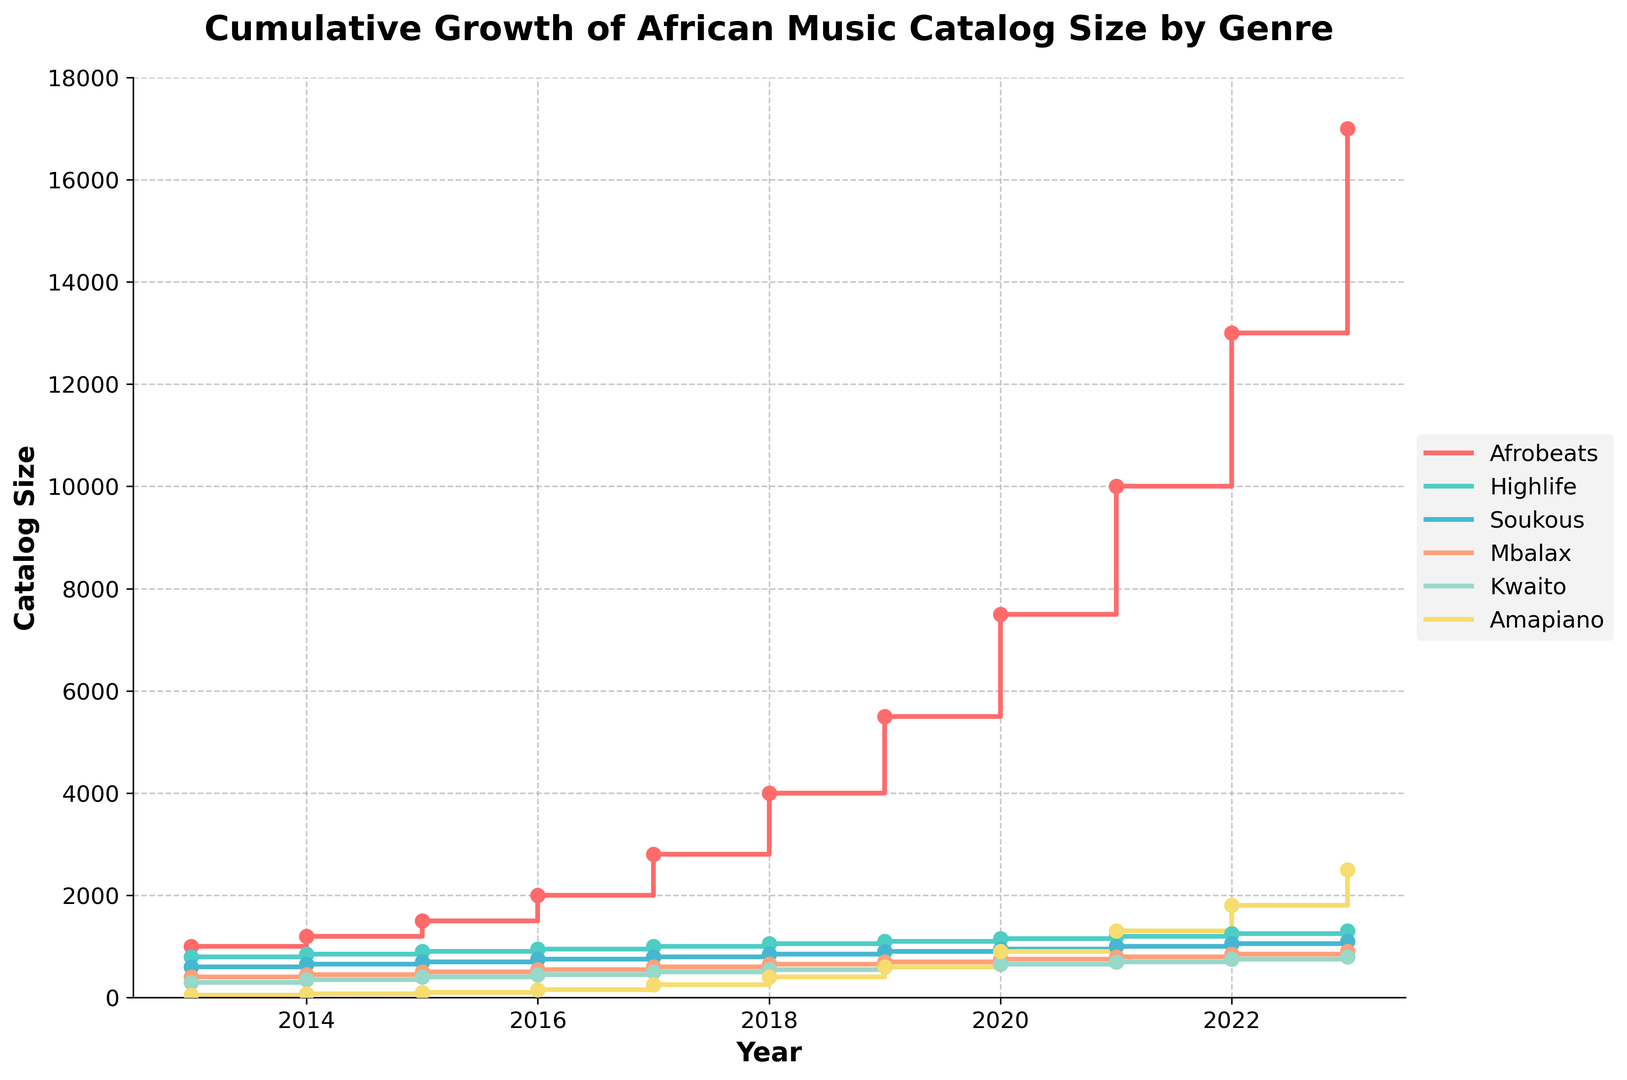Which genre has the largest catalog size growth between 2013 and 2023? To determine this, we need to look at the starting and ending catalog sizes for each genre in 2013 and 2023, respectively. Afrobeats grows from 1000 to 17000, Highlife from 800 to 1300, Soukous from 600 to 1100, Mbalax from 400 to 900, Kwaito from 300 to 800, and Amapiano from 50 to 2500. Afrobeats shows the largest growth.
Answer: Afrobeats What is the total catalog size for the genre Amapiano over the complete time range provided? To calculate this, sum the data points for Amapiano from 2013 to 2023: 50 + 75 + 100 + 150 + 250 + 400 + 600 + 900 + 1300 + 1800 + 2500. The total is 9125.
Answer: 9125 Which genre overtakes another genre in catalog size first over the decade? To find this, we need to visually inspect the points where one genre's line crosses another. Amapiano overtakes Soukous first between 2020 and 2021.
Answer: Amapiano overtakes Soukous How does the growth rate of Highlife compare to that of Mbalax from 2013 to 2023? Calculate the initial and final values for Highlife (800 to 1300) and Mbalax (400 to 900). Highlife's growth is 1300 - 800 = 500 and Mbalax's growth is 900 - 400 = 500. Both genres have the same absolute growth, but Mbalax starts at a lower value, indicating Mbalax might have a higher relative growth rate.
Answer: Both have the same absolute growth By how much did the Kwaito catalog size grow between 2015 and 2018? To calculate this, subtract the 2015 value from the 2018 value for Kwaito: 550 - 400 = 150.
Answer: 150 Which year did Afrobeats see the highest increase in catalog size compared to the previous year? Calculate the year-on-year differences for Afrobeats: 200 (2014), 300 (2015), 500 (2016), 800 (2017), 1200 (2018), 1500 (2019), 2000 (2020), 2500 (2021), 3000 (2022), 4000 (2023). The highest increase is in 2023.
Answer: 2023 What is the range of catalog sizes for Soukous over the decade? Determine the minimum and maximum values for Soukous from 2013 to 2023: 600 (2013) to 1100 (2023). The range is 1100 - 600 = 500.
Answer: 500 In 2020, which genres have catalog sizes between 500 and 1000? Look at the values for each genre in 2020: Afrobeats (7500), Highlife (1150), Soukous (950), Mbalax (750), Kwaito (650), and Amapiano (900). Mbalax, Kwaito, and Amapiano fall within this range.
Answer: Mbalax, Kwaito, Amapiano What is the average catalog size of Highlife from 2013 to 2023? Sum the values for Highlife and divide by the number of years: (800 + 850 + 900 + 950 + 1000 + 1050 + 1100 + 1150 + 1200 + 1250 + 1300) / 11 = 10595 / 11 = 963.18.
Answer: 963.18 